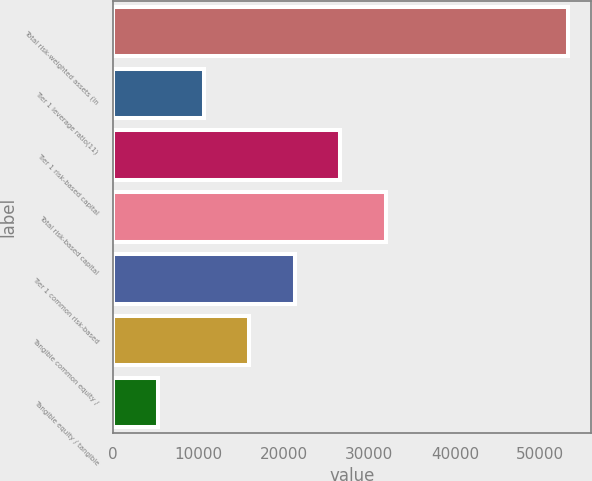<chart> <loc_0><loc_0><loc_500><loc_500><bar_chart><fcel>Total risk-weighted assets (in<fcel>Tier 1 leverage ratio(11)<fcel>Tier 1 risk-based capital<fcel>Total risk-based capital<fcel>Tier 1 common risk-based<fcel>Tangible common equity /<fcel>Tangible equity / tangible<nl><fcel>53239<fcel>10654.5<fcel>26623.7<fcel>31946.8<fcel>21300.6<fcel>15977.6<fcel>5331.42<nl></chart> 